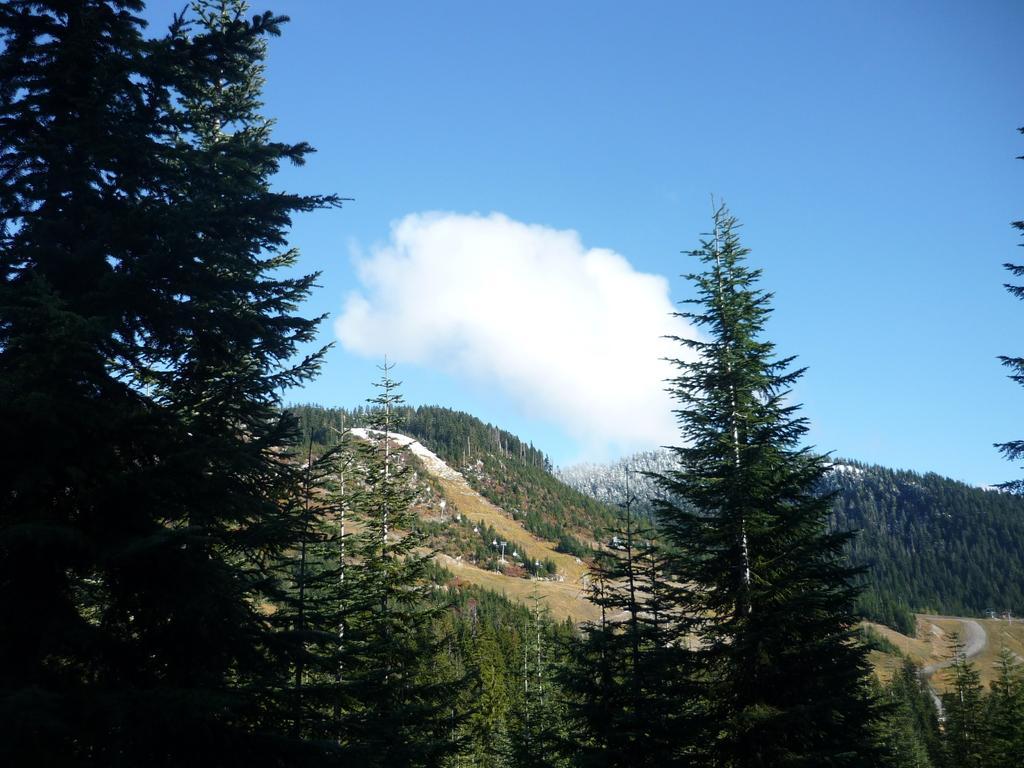Could you give a brief overview of what you see in this image? In this image I can see few trees which are green in color, the road, the ground, few mountains, few trees on the mountains and the sky in the background. 